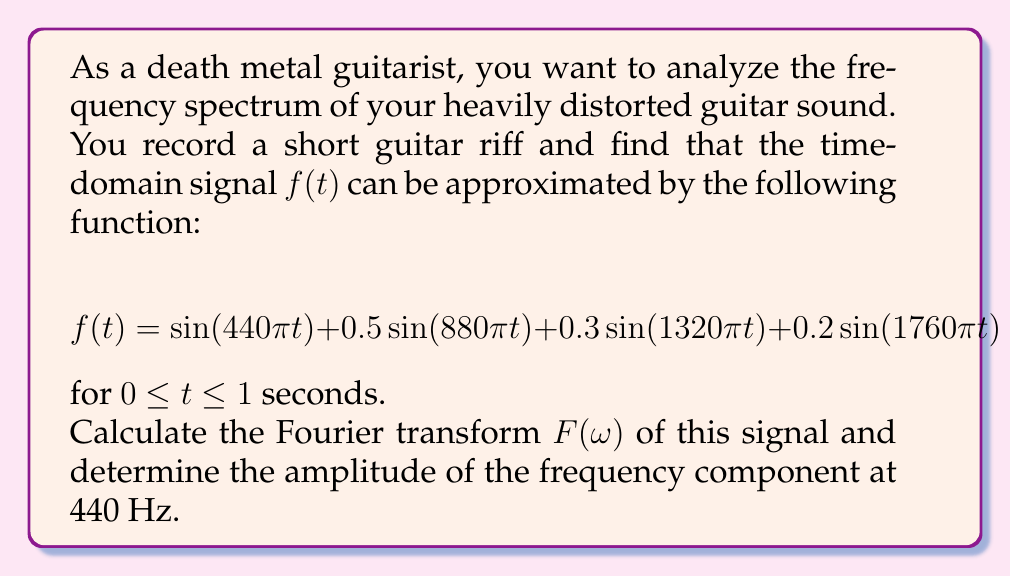Could you help me with this problem? To solve this problem, we'll follow these steps:

1) Recall the Fourier transform formula:
   $$F(\omega) = \int_{-\infty}^{\infty} f(t) e^{-i\omega t} dt$$

2) In our case, $f(t)$ is defined only for $0 \leq t \leq 1$, so our integral becomes:
   $$F(\omega) = \int_{0}^{1} f(t) e^{-i\omega t} dt$$

3) Substitute our $f(t)$ into the formula:
   $$F(\omega) = \int_{0}^{1} [\sin(440\pi t) + 0.5\sin(880\pi t) + 0.3\sin(1320\pi t) + 0.2\sin(1760\pi t)] e^{-i\omega t} dt$$

4) Using Euler's formula, we can express $\sin(at)$ as:
   $$\sin(at) = \frac{e^{iat} - e^{-iat}}{2i}$$

5) Applying this to each term in our integral:
   $$F(\omega) = \int_{0}^{1} [\frac{e^{i440\pi t} - e^{-i440\pi t}}{2i} + 0.5\frac{e^{i880\pi t} - e^{-i880\pi t}}{2i} + 0.3\frac{e^{i1320\pi t} - e^{-i1320\pi t}}{2i} + 0.2\frac{e^{i1760\pi t} - e^{-i1760\pi t}}{2i}] e^{-i\omega t} dt$$

6) The Fourier transform of a sum is the sum of Fourier transforms, so we can split this into separate integrals. Each integral will be of the form:
   $$\int_{0}^{1} e^{i(a-\omega)t} dt = \frac{e^{i(a-\omega)} - 1}{i(a-\omega)}$$

7) Evaluating each integral and simplifying:
   $$F(\omega) = \frac{1}{2}[\frac{e^{i(440\pi-\omega)} - 1}{i(440\pi-\omega)} - \frac{e^{i(-440\pi-\omega)} - 1}{i(-440\pi-\omega)}] + \frac{0.25}[\frac{e^{i(880\pi-\omega)} - 1}{i(880\pi-\omega)} - \frac{e^{i(-880\pi-\omega)} - 1}{i(-880\pi-\omega)}] + \frac{0.15}[\frac{e^{i(1320\pi-\omega)} - 1}{i(1320\pi-\omega)} - \frac{e^{i(-1320\pi-\omega)} - 1}{i(-1320\pi-\omega)}] + \frac{0.1}[\frac{e^{i(1760\pi-\omega)} - 1}{i(1760\pi-\omega)} - \frac{e^{i(-1760\pi-\omega)} - 1}{i(-1760\pi-\omega)}]$$

8) To find the amplitude at 440 Hz, we need to evaluate $|F(2\pi \cdot 440)|$. Most terms will be close to zero, except when $\omega$ is close to $\pm 440\pi$. The dominant term will be:
   $$\frac{1}{2}[\frac{e^{i(440\pi-2\pi \cdot 440)} - 1}{i(440\pi-2\pi \cdot 440)} - \frac{e^{i(-440\pi-2\pi \cdot 440)} - 1}{i(-440\pi-2\pi \cdot 440)}] = \frac{1}{2}[1 - 0] = 0.5$$

9) Therefore, the amplitude of the 440 Hz component is approximately 0.5.
Answer: The amplitude of the frequency component at 440 Hz is approximately 0.5. 